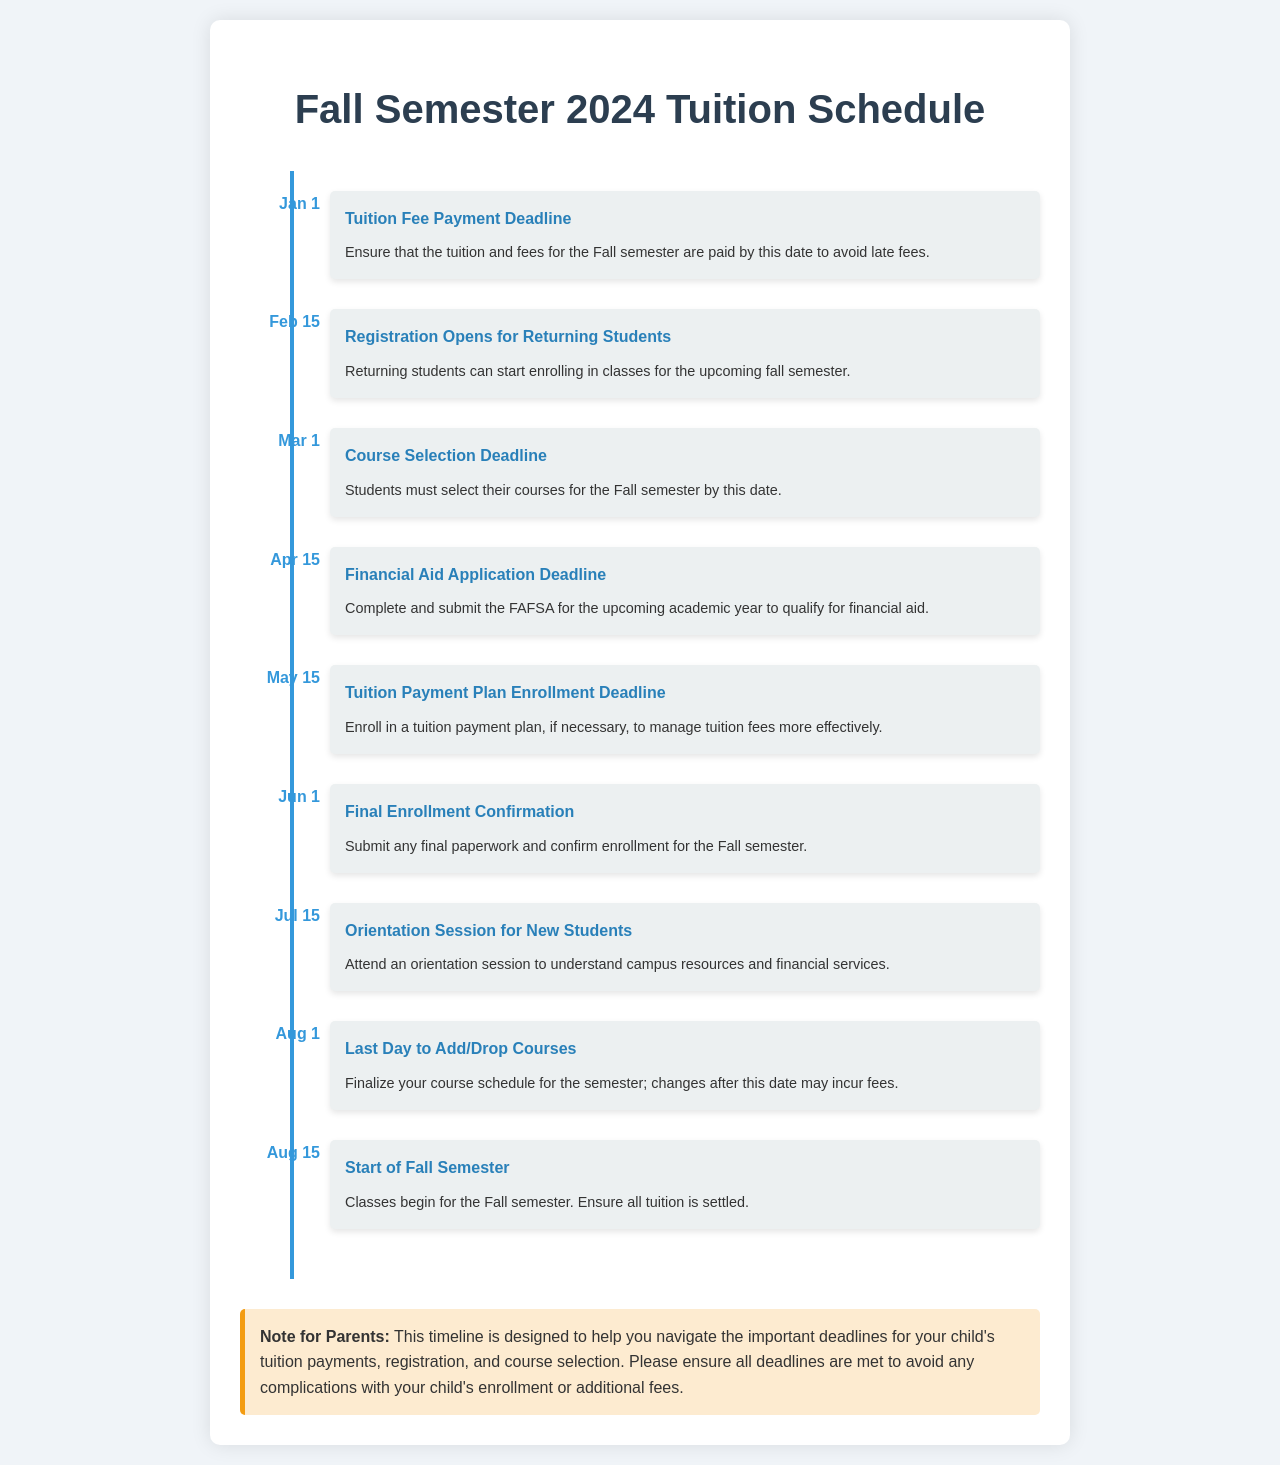What is the tuition payment deadline? The tuition payment deadline is the date by which the tuition and fees must be paid to avoid late charges, which is listed as January 1.
Answer: January 1 When does registration open for returning students? The document states that registration for returning students opens on February 15.
Answer: February 15 What is the course selection deadline? The course selection deadline is when students must choose their courses for the Fall semester, which is March 1.
Answer: March 1 When is the financial aid application deadline? The deadline to complete and submit the FAFSA for financial aid is indicated as April 15.
Answer: April 15 What is the last day to add/drop courses? The last day for students to finalize their course schedule without incurring fees is listed as August 1.
Answer: August 1 What resources are available at the orientation session? The orientation session helps new students understand campus resources and financial services, as mentioned in the document.
Answer: Campus resources and financial services If a student misses the enrollment confirmation date, what is the date they need to remember? The final enrollment confirmation must be submitted by June 1.
Answer: June 1 What should students ensure before the start of the Fall semester? Students should ensure that all tuition is settled before classes begin.
Answer: All tuition is settled When is the start date of the Fall semester? The document specifies that classes begin on August 15.
Answer: August 15 